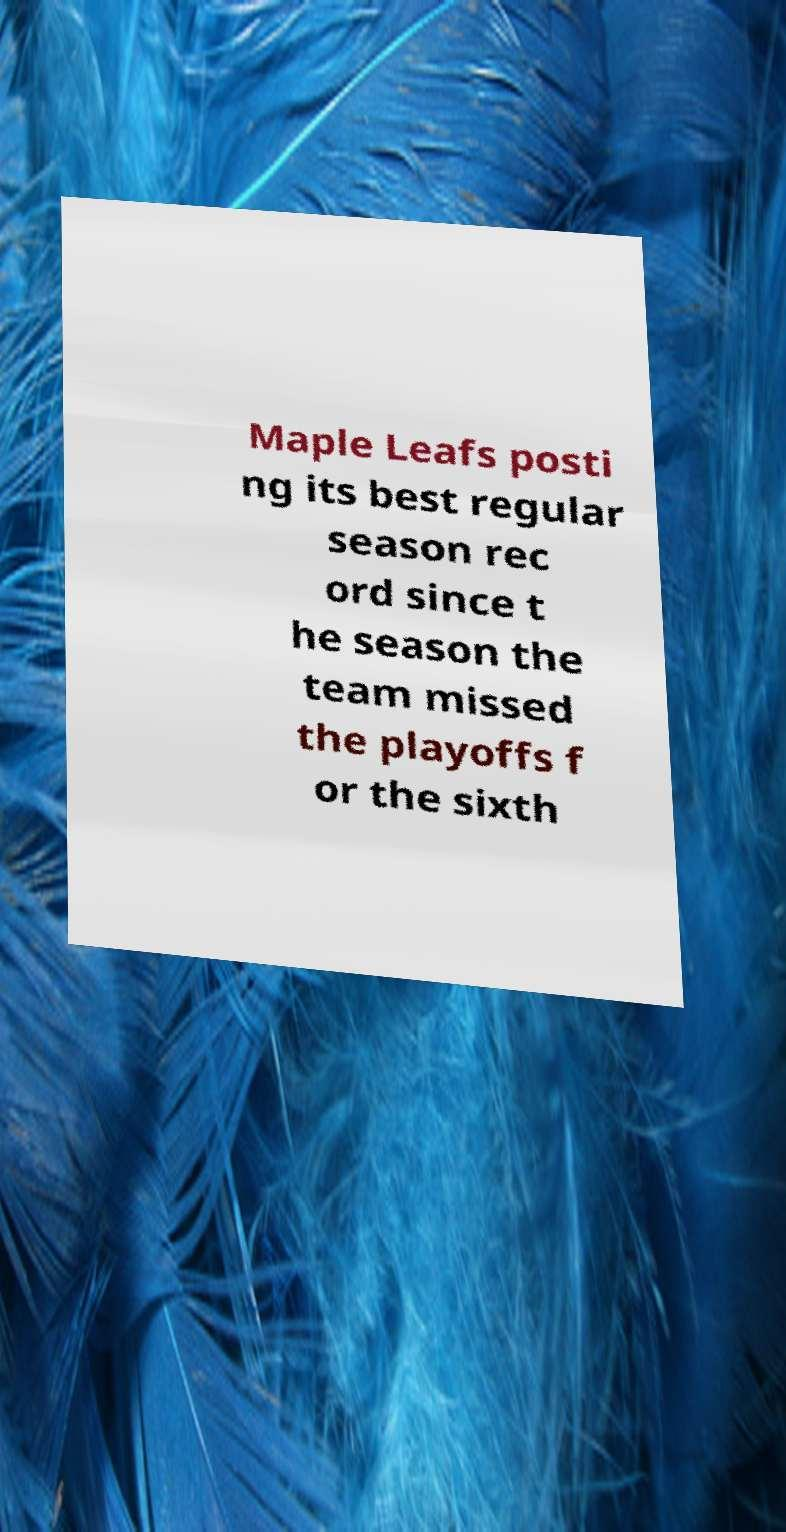Could you extract and type out the text from this image? Maple Leafs posti ng its best regular season rec ord since t he season the team missed the playoffs f or the sixth 